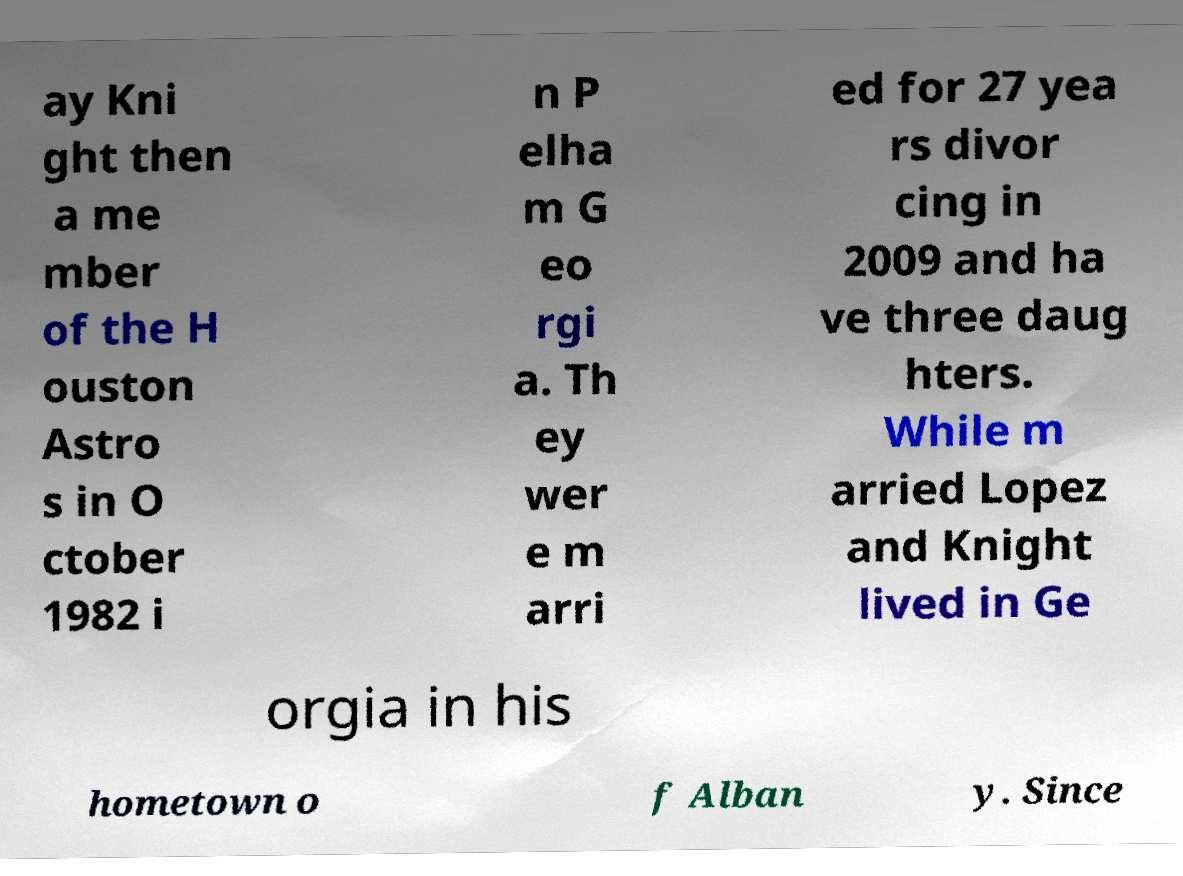For documentation purposes, I need the text within this image transcribed. Could you provide that? ay Kni ght then a me mber of the H ouston Astro s in O ctober 1982 i n P elha m G eo rgi a. Th ey wer e m arri ed for 27 yea rs divor cing in 2009 and ha ve three daug hters. While m arried Lopez and Knight lived in Ge orgia in his hometown o f Alban y. Since 